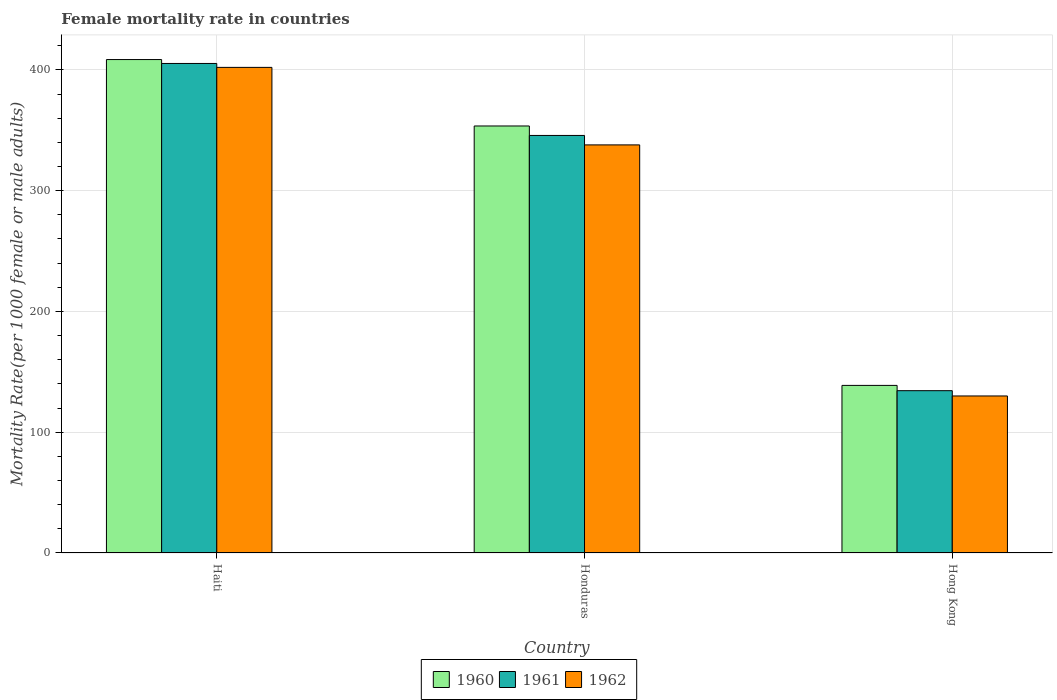How many different coloured bars are there?
Provide a short and direct response. 3. How many groups of bars are there?
Your answer should be very brief. 3. Are the number of bars per tick equal to the number of legend labels?
Offer a very short reply. Yes. How many bars are there on the 1st tick from the left?
Offer a terse response. 3. What is the label of the 3rd group of bars from the left?
Offer a terse response. Hong Kong. What is the female mortality rate in 1960 in Honduras?
Your answer should be very brief. 353.57. Across all countries, what is the maximum female mortality rate in 1960?
Ensure brevity in your answer.  408.58. Across all countries, what is the minimum female mortality rate in 1960?
Offer a very short reply. 138.77. In which country was the female mortality rate in 1960 maximum?
Provide a succinct answer. Haiti. In which country was the female mortality rate in 1960 minimum?
Your answer should be compact. Hong Kong. What is the total female mortality rate in 1961 in the graph?
Give a very brief answer. 885.48. What is the difference between the female mortality rate in 1961 in Haiti and that in Honduras?
Ensure brevity in your answer.  59.6. What is the difference between the female mortality rate in 1962 in Honduras and the female mortality rate in 1960 in Haiti?
Make the answer very short. -70.67. What is the average female mortality rate in 1962 per country?
Offer a terse response. 290.01. What is the difference between the female mortality rate of/in 1962 and female mortality rate of/in 1961 in Honduras?
Provide a short and direct response. -7.83. What is the ratio of the female mortality rate in 1962 in Haiti to that in Honduras?
Keep it short and to the point. 1.19. Is the female mortality rate in 1962 in Haiti less than that in Hong Kong?
Provide a succinct answer. No. What is the difference between the highest and the second highest female mortality rate in 1962?
Offer a terse response. -64.19. What is the difference between the highest and the lowest female mortality rate in 1961?
Keep it short and to the point. 270.95. Is the sum of the female mortality rate in 1962 in Haiti and Honduras greater than the maximum female mortality rate in 1960 across all countries?
Keep it short and to the point. Yes. Is it the case that in every country, the sum of the female mortality rate in 1960 and female mortality rate in 1961 is greater than the female mortality rate in 1962?
Offer a terse response. Yes. How many bars are there?
Offer a terse response. 9. Are all the bars in the graph horizontal?
Your response must be concise. No. Are the values on the major ticks of Y-axis written in scientific E-notation?
Your answer should be compact. No. Does the graph contain any zero values?
Keep it short and to the point. No. What is the title of the graph?
Offer a terse response. Female mortality rate in countries. Does "1985" appear as one of the legend labels in the graph?
Provide a short and direct response. No. What is the label or title of the X-axis?
Offer a terse response. Country. What is the label or title of the Y-axis?
Make the answer very short. Mortality Rate(per 1000 female or male adults). What is the Mortality Rate(per 1000 female or male adults) of 1960 in Haiti?
Your answer should be compact. 408.58. What is the Mortality Rate(per 1000 female or male adults) of 1961 in Haiti?
Offer a very short reply. 405.34. What is the Mortality Rate(per 1000 female or male adults) of 1962 in Haiti?
Your response must be concise. 402.1. What is the Mortality Rate(per 1000 female or male adults) in 1960 in Honduras?
Offer a very short reply. 353.57. What is the Mortality Rate(per 1000 female or male adults) of 1961 in Honduras?
Provide a succinct answer. 345.74. What is the Mortality Rate(per 1000 female or male adults) in 1962 in Honduras?
Provide a succinct answer. 337.91. What is the Mortality Rate(per 1000 female or male adults) of 1960 in Hong Kong?
Your answer should be very brief. 138.77. What is the Mortality Rate(per 1000 female or male adults) of 1961 in Hong Kong?
Your answer should be very brief. 134.39. What is the Mortality Rate(per 1000 female or male adults) of 1962 in Hong Kong?
Make the answer very short. 130.02. Across all countries, what is the maximum Mortality Rate(per 1000 female or male adults) in 1960?
Your answer should be very brief. 408.58. Across all countries, what is the maximum Mortality Rate(per 1000 female or male adults) of 1961?
Offer a very short reply. 405.34. Across all countries, what is the maximum Mortality Rate(per 1000 female or male adults) of 1962?
Offer a terse response. 402.1. Across all countries, what is the minimum Mortality Rate(per 1000 female or male adults) in 1960?
Keep it short and to the point. 138.77. Across all countries, what is the minimum Mortality Rate(per 1000 female or male adults) in 1961?
Your answer should be very brief. 134.39. Across all countries, what is the minimum Mortality Rate(per 1000 female or male adults) in 1962?
Your response must be concise. 130.02. What is the total Mortality Rate(per 1000 female or male adults) of 1960 in the graph?
Ensure brevity in your answer.  900.93. What is the total Mortality Rate(per 1000 female or male adults) of 1961 in the graph?
Offer a terse response. 885.48. What is the total Mortality Rate(per 1000 female or male adults) in 1962 in the graph?
Your response must be concise. 870.03. What is the difference between the Mortality Rate(per 1000 female or male adults) of 1960 in Haiti and that in Honduras?
Offer a terse response. 55.01. What is the difference between the Mortality Rate(per 1000 female or male adults) in 1961 in Haiti and that in Honduras?
Your answer should be compact. 59.6. What is the difference between the Mortality Rate(per 1000 female or male adults) of 1962 in Haiti and that in Honduras?
Your answer should be compact. 64.19. What is the difference between the Mortality Rate(per 1000 female or male adults) of 1960 in Haiti and that in Hong Kong?
Your response must be concise. 269.81. What is the difference between the Mortality Rate(per 1000 female or male adults) of 1961 in Haiti and that in Hong Kong?
Your answer should be very brief. 270.95. What is the difference between the Mortality Rate(per 1000 female or male adults) in 1962 in Haiti and that in Hong Kong?
Offer a terse response. 272.08. What is the difference between the Mortality Rate(per 1000 female or male adults) in 1960 in Honduras and that in Hong Kong?
Your answer should be compact. 214.8. What is the difference between the Mortality Rate(per 1000 female or male adults) in 1961 in Honduras and that in Hong Kong?
Give a very brief answer. 211.35. What is the difference between the Mortality Rate(per 1000 female or male adults) of 1962 in Honduras and that in Hong Kong?
Offer a very short reply. 207.89. What is the difference between the Mortality Rate(per 1000 female or male adults) in 1960 in Haiti and the Mortality Rate(per 1000 female or male adults) in 1961 in Honduras?
Your answer should be very brief. 62.84. What is the difference between the Mortality Rate(per 1000 female or male adults) in 1960 in Haiti and the Mortality Rate(per 1000 female or male adults) in 1962 in Honduras?
Give a very brief answer. 70.67. What is the difference between the Mortality Rate(per 1000 female or male adults) in 1961 in Haiti and the Mortality Rate(per 1000 female or male adults) in 1962 in Honduras?
Make the answer very short. 67.43. What is the difference between the Mortality Rate(per 1000 female or male adults) in 1960 in Haiti and the Mortality Rate(per 1000 female or male adults) in 1961 in Hong Kong?
Give a very brief answer. 274.19. What is the difference between the Mortality Rate(per 1000 female or male adults) in 1960 in Haiti and the Mortality Rate(per 1000 female or male adults) in 1962 in Hong Kong?
Make the answer very short. 278.57. What is the difference between the Mortality Rate(per 1000 female or male adults) of 1961 in Haiti and the Mortality Rate(per 1000 female or male adults) of 1962 in Hong Kong?
Give a very brief answer. 275.32. What is the difference between the Mortality Rate(per 1000 female or male adults) in 1960 in Honduras and the Mortality Rate(per 1000 female or male adults) in 1961 in Hong Kong?
Offer a terse response. 219.18. What is the difference between the Mortality Rate(per 1000 female or male adults) in 1960 in Honduras and the Mortality Rate(per 1000 female or male adults) in 1962 in Hong Kong?
Your answer should be very brief. 223.56. What is the difference between the Mortality Rate(per 1000 female or male adults) of 1961 in Honduras and the Mortality Rate(per 1000 female or male adults) of 1962 in Hong Kong?
Keep it short and to the point. 215.72. What is the average Mortality Rate(per 1000 female or male adults) in 1960 per country?
Provide a short and direct response. 300.31. What is the average Mortality Rate(per 1000 female or male adults) of 1961 per country?
Keep it short and to the point. 295.16. What is the average Mortality Rate(per 1000 female or male adults) in 1962 per country?
Your answer should be compact. 290.01. What is the difference between the Mortality Rate(per 1000 female or male adults) of 1960 and Mortality Rate(per 1000 female or male adults) of 1961 in Haiti?
Make the answer very short. 3.24. What is the difference between the Mortality Rate(per 1000 female or male adults) in 1960 and Mortality Rate(per 1000 female or male adults) in 1962 in Haiti?
Make the answer very short. 6.48. What is the difference between the Mortality Rate(per 1000 female or male adults) in 1961 and Mortality Rate(per 1000 female or male adults) in 1962 in Haiti?
Provide a short and direct response. 3.24. What is the difference between the Mortality Rate(per 1000 female or male adults) of 1960 and Mortality Rate(per 1000 female or male adults) of 1961 in Honduras?
Ensure brevity in your answer.  7.83. What is the difference between the Mortality Rate(per 1000 female or male adults) of 1960 and Mortality Rate(per 1000 female or male adults) of 1962 in Honduras?
Your answer should be very brief. 15.66. What is the difference between the Mortality Rate(per 1000 female or male adults) in 1961 and Mortality Rate(per 1000 female or male adults) in 1962 in Honduras?
Ensure brevity in your answer.  7.83. What is the difference between the Mortality Rate(per 1000 female or male adults) in 1960 and Mortality Rate(per 1000 female or male adults) in 1961 in Hong Kong?
Your answer should be compact. 4.38. What is the difference between the Mortality Rate(per 1000 female or male adults) in 1960 and Mortality Rate(per 1000 female or male adults) in 1962 in Hong Kong?
Offer a terse response. 8.75. What is the difference between the Mortality Rate(per 1000 female or male adults) of 1961 and Mortality Rate(per 1000 female or male adults) of 1962 in Hong Kong?
Ensure brevity in your answer.  4.38. What is the ratio of the Mortality Rate(per 1000 female or male adults) of 1960 in Haiti to that in Honduras?
Your answer should be compact. 1.16. What is the ratio of the Mortality Rate(per 1000 female or male adults) in 1961 in Haiti to that in Honduras?
Your answer should be very brief. 1.17. What is the ratio of the Mortality Rate(per 1000 female or male adults) of 1962 in Haiti to that in Honduras?
Ensure brevity in your answer.  1.19. What is the ratio of the Mortality Rate(per 1000 female or male adults) in 1960 in Haiti to that in Hong Kong?
Provide a short and direct response. 2.94. What is the ratio of the Mortality Rate(per 1000 female or male adults) of 1961 in Haiti to that in Hong Kong?
Make the answer very short. 3.02. What is the ratio of the Mortality Rate(per 1000 female or male adults) of 1962 in Haiti to that in Hong Kong?
Provide a short and direct response. 3.09. What is the ratio of the Mortality Rate(per 1000 female or male adults) in 1960 in Honduras to that in Hong Kong?
Your answer should be compact. 2.55. What is the ratio of the Mortality Rate(per 1000 female or male adults) in 1961 in Honduras to that in Hong Kong?
Make the answer very short. 2.57. What is the ratio of the Mortality Rate(per 1000 female or male adults) of 1962 in Honduras to that in Hong Kong?
Your answer should be very brief. 2.6. What is the difference between the highest and the second highest Mortality Rate(per 1000 female or male adults) of 1960?
Provide a short and direct response. 55.01. What is the difference between the highest and the second highest Mortality Rate(per 1000 female or male adults) in 1961?
Your response must be concise. 59.6. What is the difference between the highest and the second highest Mortality Rate(per 1000 female or male adults) in 1962?
Your answer should be very brief. 64.19. What is the difference between the highest and the lowest Mortality Rate(per 1000 female or male adults) in 1960?
Give a very brief answer. 269.81. What is the difference between the highest and the lowest Mortality Rate(per 1000 female or male adults) of 1961?
Your answer should be compact. 270.95. What is the difference between the highest and the lowest Mortality Rate(per 1000 female or male adults) in 1962?
Your answer should be very brief. 272.08. 